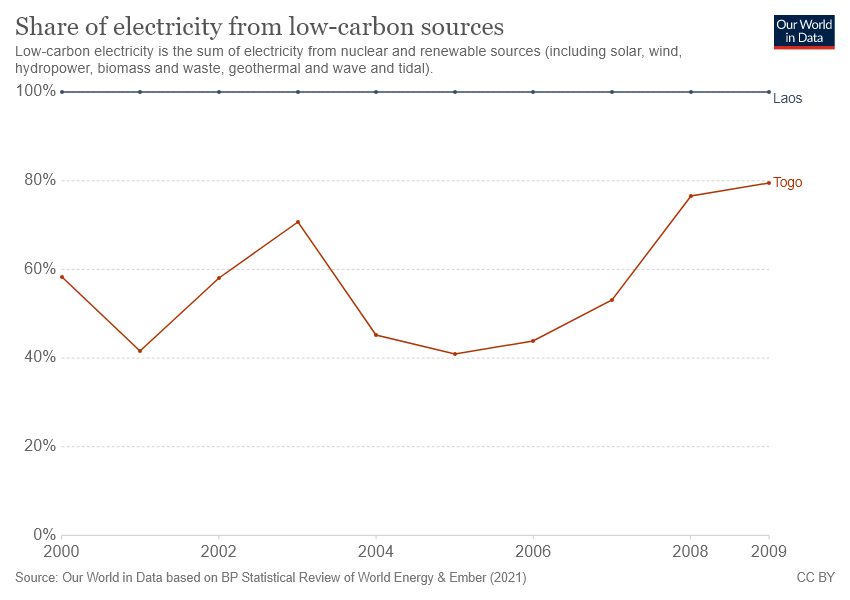Point out several critical features in this image. When the line representing Togo reaches the peak in 2009. The brown line represents Togo in the given map. 